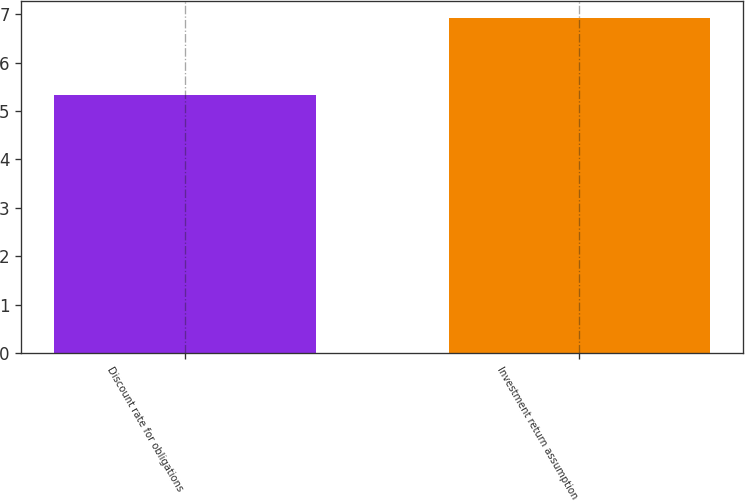Convert chart. <chart><loc_0><loc_0><loc_500><loc_500><bar_chart><fcel>Discount rate for obligations<fcel>Investment return assumption<nl><fcel>5.34<fcel>6.93<nl></chart> 